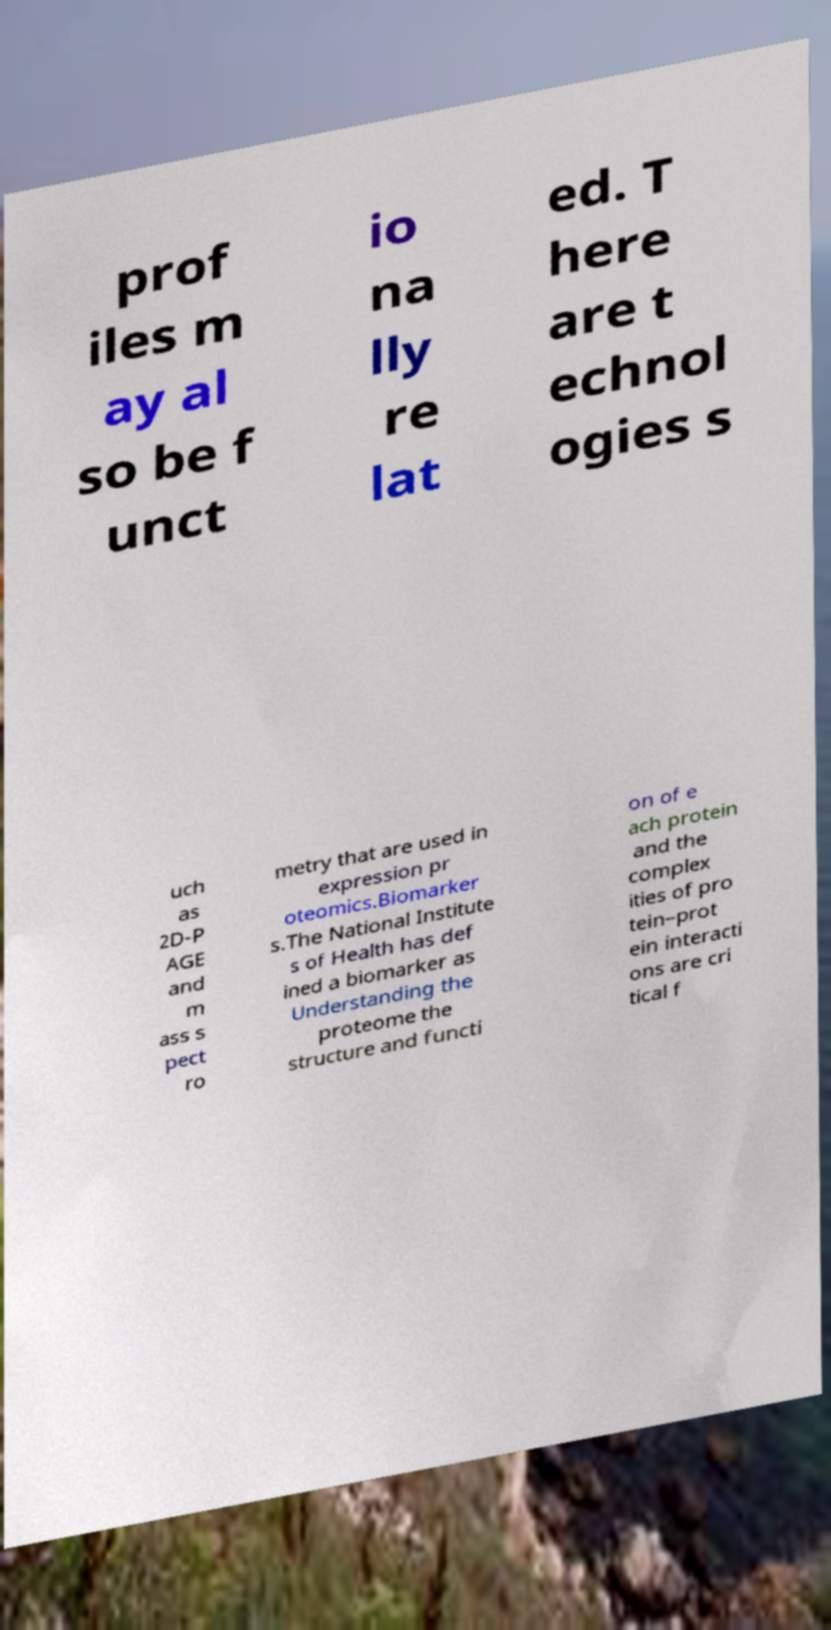Could you assist in decoding the text presented in this image and type it out clearly? prof iles m ay al so be f unct io na lly re lat ed. T here are t echnol ogies s uch as 2D-P AGE and m ass s pect ro metry that are used in expression pr oteomics.Biomarker s.The National Institute s of Health has def ined a biomarker as Understanding the proteome the structure and functi on of e ach protein and the complex ities of pro tein–prot ein interacti ons are cri tical f 